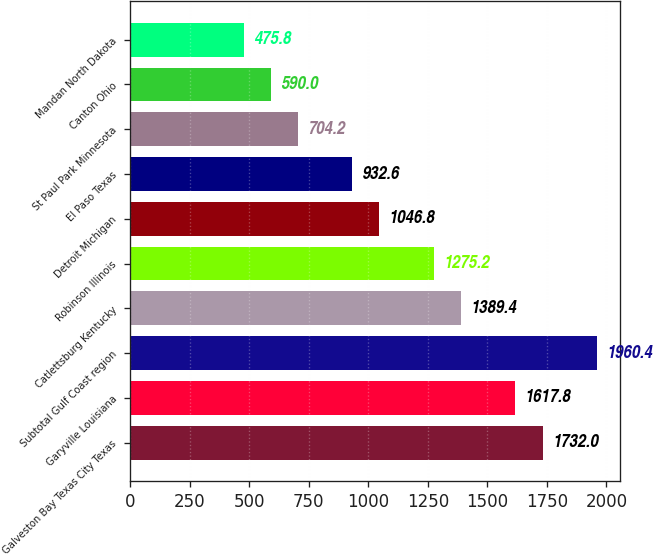Convert chart to OTSL. <chart><loc_0><loc_0><loc_500><loc_500><bar_chart><fcel>Galveston Bay Texas City Texas<fcel>Garyville Louisiana<fcel>Subtotal Gulf Coast region<fcel>Catlettsburg Kentucky<fcel>Robinson Illinois<fcel>Detroit Michigan<fcel>El Paso Texas<fcel>St Paul Park Minnesota<fcel>Canton Ohio<fcel>Mandan North Dakota<nl><fcel>1732<fcel>1617.8<fcel>1960.4<fcel>1389.4<fcel>1275.2<fcel>1046.8<fcel>932.6<fcel>704.2<fcel>590<fcel>475.8<nl></chart> 